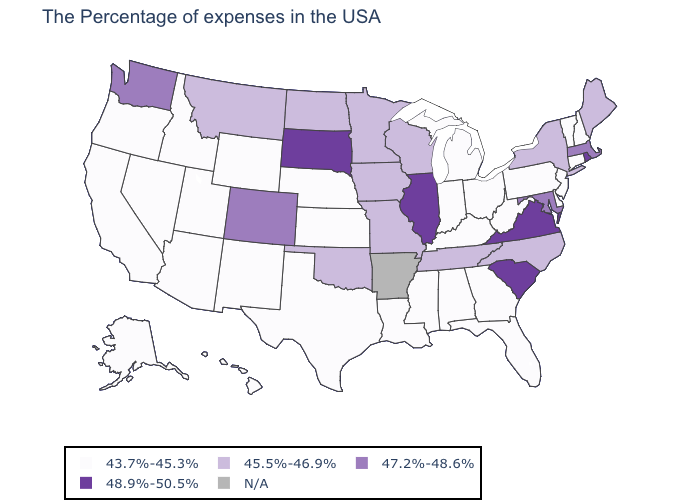What is the value of New Jersey?
Keep it brief. 43.7%-45.3%. What is the value of Maine?
Concise answer only. 45.5%-46.9%. Among the states that border Tennessee , does Mississippi have the highest value?
Concise answer only. No. What is the value of Hawaii?
Be succinct. 43.7%-45.3%. What is the highest value in states that border Indiana?
Quick response, please. 48.9%-50.5%. What is the lowest value in states that border Iowa?
Give a very brief answer. 43.7%-45.3%. What is the value of Tennessee?
Write a very short answer. 45.5%-46.9%. What is the value of Washington?
Quick response, please. 47.2%-48.6%. Does the first symbol in the legend represent the smallest category?
Answer briefly. Yes. What is the lowest value in the USA?
Answer briefly. 43.7%-45.3%. What is the value of Georgia?
Answer briefly. 43.7%-45.3%. Does Tennessee have the lowest value in the USA?
Concise answer only. No. 